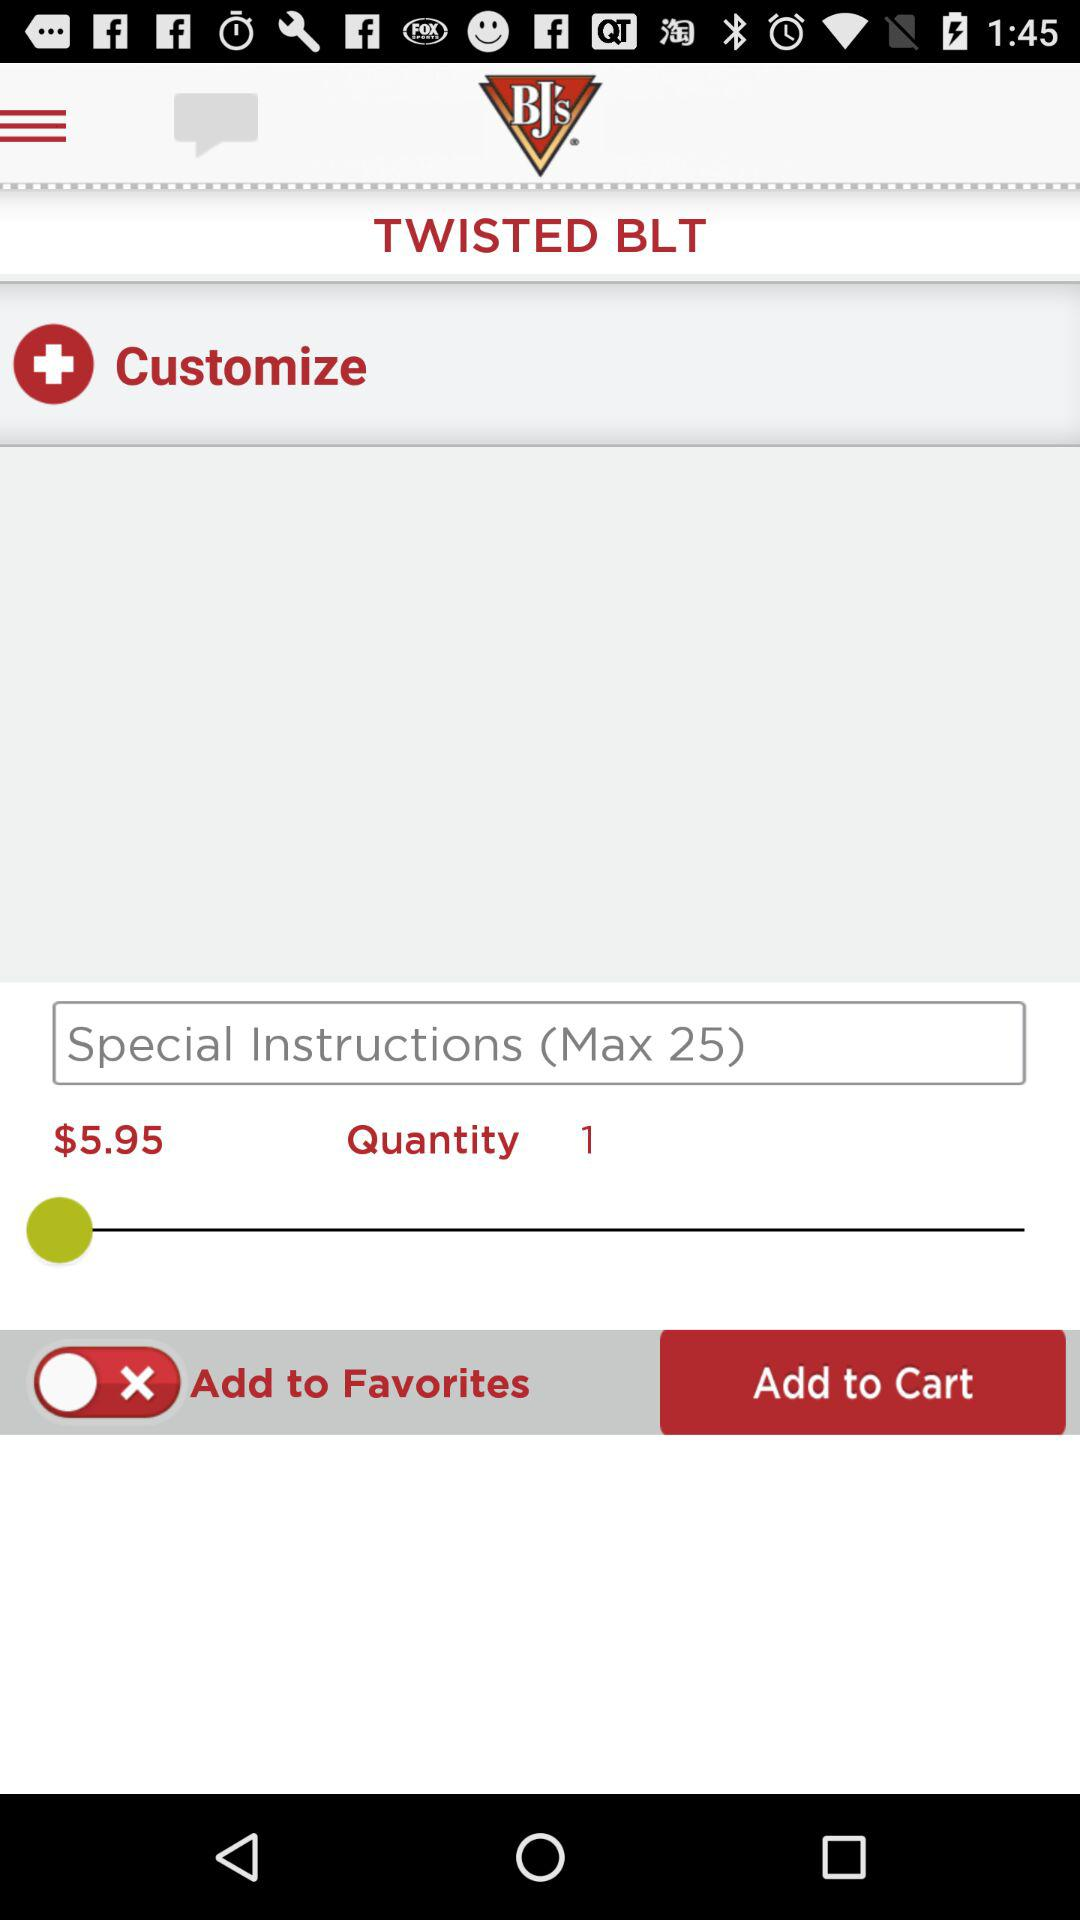What is the quantity? The quantity is 1. 